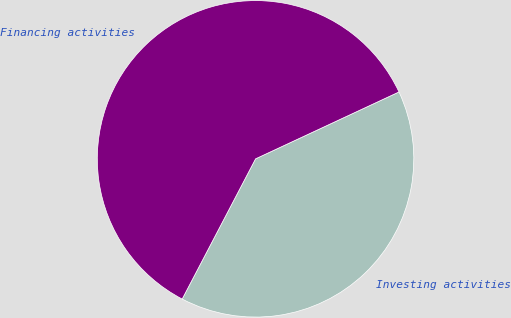Convert chart. <chart><loc_0><loc_0><loc_500><loc_500><pie_chart><fcel>Investing activities<fcel>Financing activities<nl><fcel>39.62%<fcel>60.38%<nl></chart> 